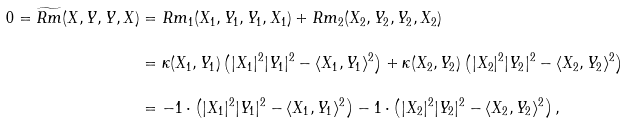<formula> <loc_0><loc_0><loc_500><loc_500>0 = \widetilde { R m } ( X , Y , Y , X ) & = R m _ { 1 } ( X _ { 1 } , Y _ { 1 } , Y _ { 1 } , X _ { 1 } ) + R m _ { 2 } ( X _ { 2 } , Y _ { 2 } , Y _ { 2 } , X _ { 2 } ) \\ & = \kappa ( X _ { 1 } , Y _ { 1 } ) \left ( | X _ { 1 } | ^ { 2 } | Y _ { 1 } | ^ { 2 } - \langle X _ { 1 } , Y _ { 1 } \rangle ^ { 2 } \right ) + \kappa ( X _ { 2 } , Y _ { 2 } ) \left ( | X _ { 2 } | ^ { 2 } | Y _ { 2 } | ^ { 2 } - \langle X _ { 2 } , Y _ { 2 } \rangle ^ { 2 } \right ) \\ & = - 1 \cdot \left ( | X _ { 1 } | ^ { 2 } | Y _ { 1 } | ^ { 2 } - \langle X _ { 1 } , Y _ { 1 } \rangle ^ { 2 } \right ) - 1 \cdot \left ( | X _ { 2 } | ^ { 2 } | Y _ { 2 } | ^ { 2 } - \langle X _ { 2 } , Y _ { 2 } \rangle ^ { 2 } \right ) ,</formula> 